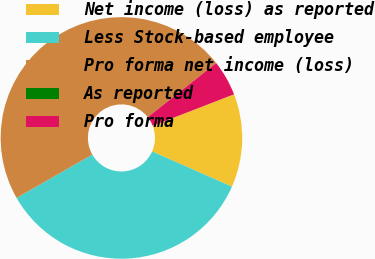Convert chart. <chart><loc_0><loc_0><loc_500><loc_500><pie_chart><fcel>Net income (loss) as reported<fcel>Less Stock-based employee<fcel>Pro forma net income (loss)<fcel>As reported<fcel>Pro forma<nl><fcel>12.49%<fcel>35.12%<fcel>47.62%<fcel>0.0%<fcel>4.76%<nl></chart> 